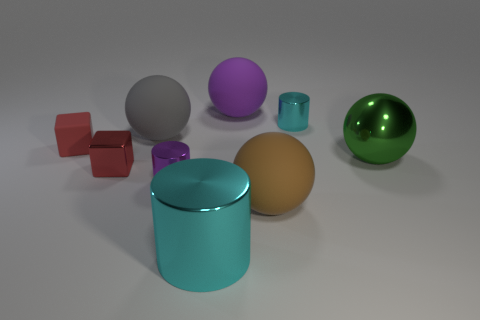There is a matte thing that is the same color as the metallic block; what is its shape?
Keep it short and to the point. Cube. Is there another tiny object that has the same color as the tiny matte object?
Your answer should be very brief. Yes. There is a metal object that is the same color as the large cylinder; what size is it?
Ensure brevity in your answer.  Small. What shape is the small thing that is both on the right side of the tiny metal cube and behind the green shiny ball?
Your answer should be compact. Cylinder. How many other things are there of the same shape as the small cyan metal thing?
Provide a succinct answer. 2. How big is the purple metallic object?
Your answer should be compact. Small. How many objects are big blue rubber cylinders or cubes?
Provide a short and direct response. 2. There is a matte ball that is behind the tiny cyan cylinder; what is its size?
Provide a succinct answer. Large. The tiny thing that is both left of the big gray rubber sphere and behind the large green shiny thing is what color?
Keep it short and to the point. Red. Does the tiny cube behind the small metal cube have the same material as the small cyan object?
Provide a short and direct response. No. 